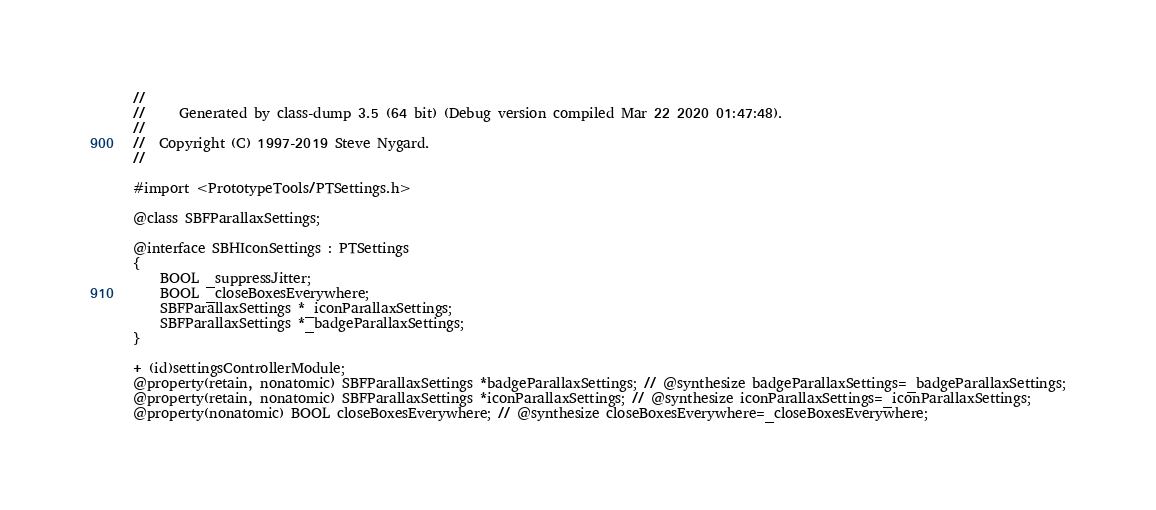<code> <loc_0><loc_0><loc_500><loc_500><_C_>//
//     Generated by class-dump 3.5 (64 bit) (Debug version compiled Mar 22 2020 01:47:48).
//
//  Copyright (C) 1997-2019 Steve Nygard.
//

#import <PrototypeTools/PTSettings.h>

@class SBFParallaxSettings;

@interface SBHIconSettings : PTSettings
{
    BOOL _suppressJitter;
    BOOL _closeBoxesEverywhere;
    SBFParallaxSettings *_iconParallaxSettings;
    SBFParallaxSettings *_badgeParallaxSettings;
}

+ (id)settingsControllerModule;
@property(retain, nonatomic) SBFParallaxSettings *badgeParallaxSettings; // @synthesize badgeParallaxSettings=_badgeParallaxSettings;
@property(retain, nonatomic) SBFParallaxSettings *iconParallaxSettings; // @synthesize iconParallaxSettings=_iconParallaxSettings;
@property(nonatomic) BOOL closeBoxesEverywhere; // @synthesize closeBoxesEverywhere=_closeBoxesEverywhere;</code> 